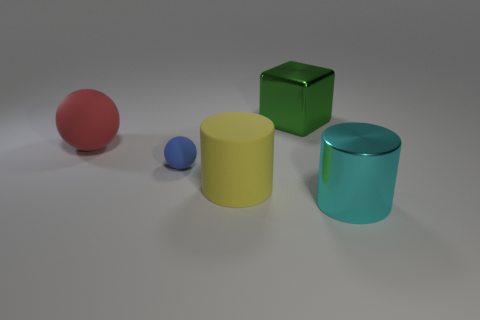Add 3 small things. How many objects exist? 8 Subtract all cylinders. How many objects are left? 3 Add 3 rubber objects. How many rubber objects are left? 6 Add 5 tiny green metal cylinders. How many tiny green metal cylinders exist? 5 Subtract 0 red cylinders. How many objects are left? 5 Subtract all large cyan metal objects. Subtract all big things. How many objects are left? 0 